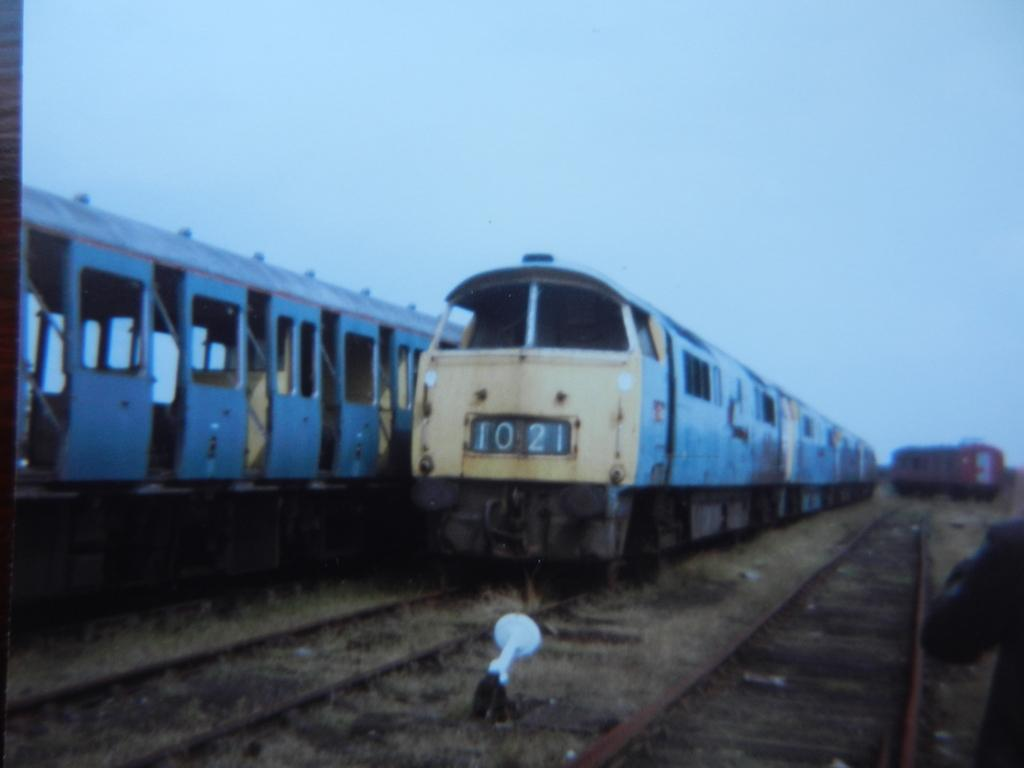What can be seen on the track in the image? There are two trains visible on a track in the image. Are there any other trains in the image? Yes, there is another train on the right side of the image. What is visible at the top of the image? The sky is visible at the top of the image. What object can be seen on the floor in the middle of the image? There is an object kept on the floor in the middle of the image. Can you see a robin perched on the train in the image? There is no robin present in the image. Is there a zipper on the train in the image? There is no zipper visible on the train in the image. 